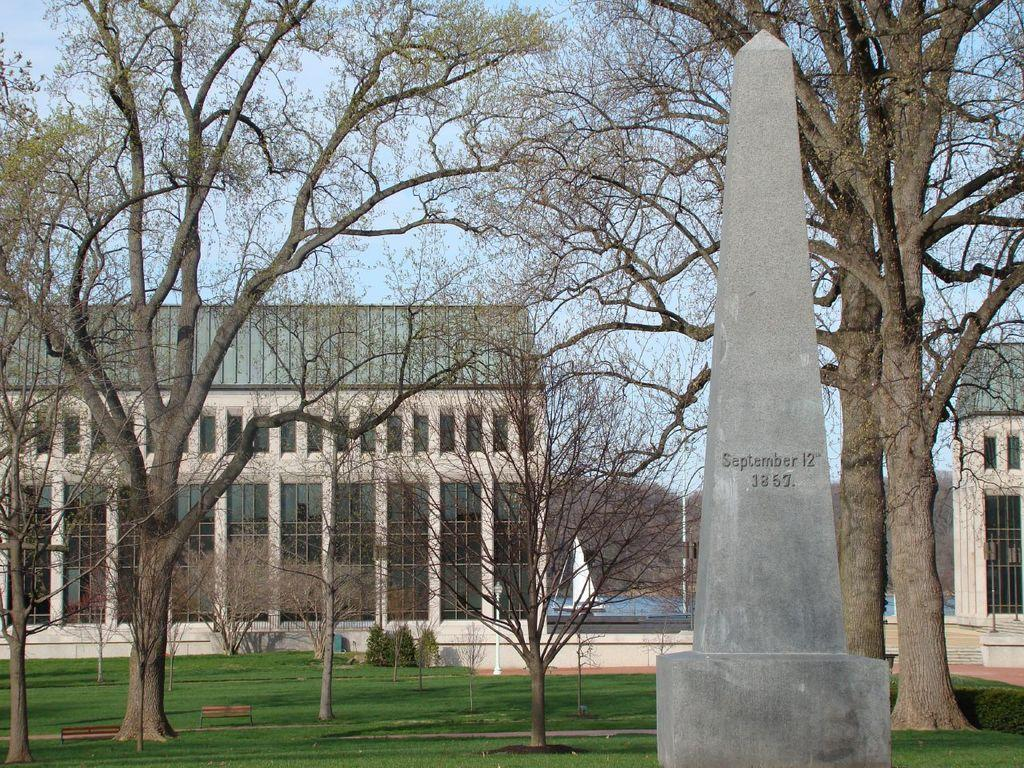What type of structure is visible in the image? There is a building in the image. What feature of the building is mentioned in the facts? The building has windows. What else can be seen in the image besides the building? There is a concrete pillar, grass, trees, and plants in the image. What is written on the pillar? There is text on the pillar. What word is being taught in the image? There is no indication of any teaching or learning activity in the image. 